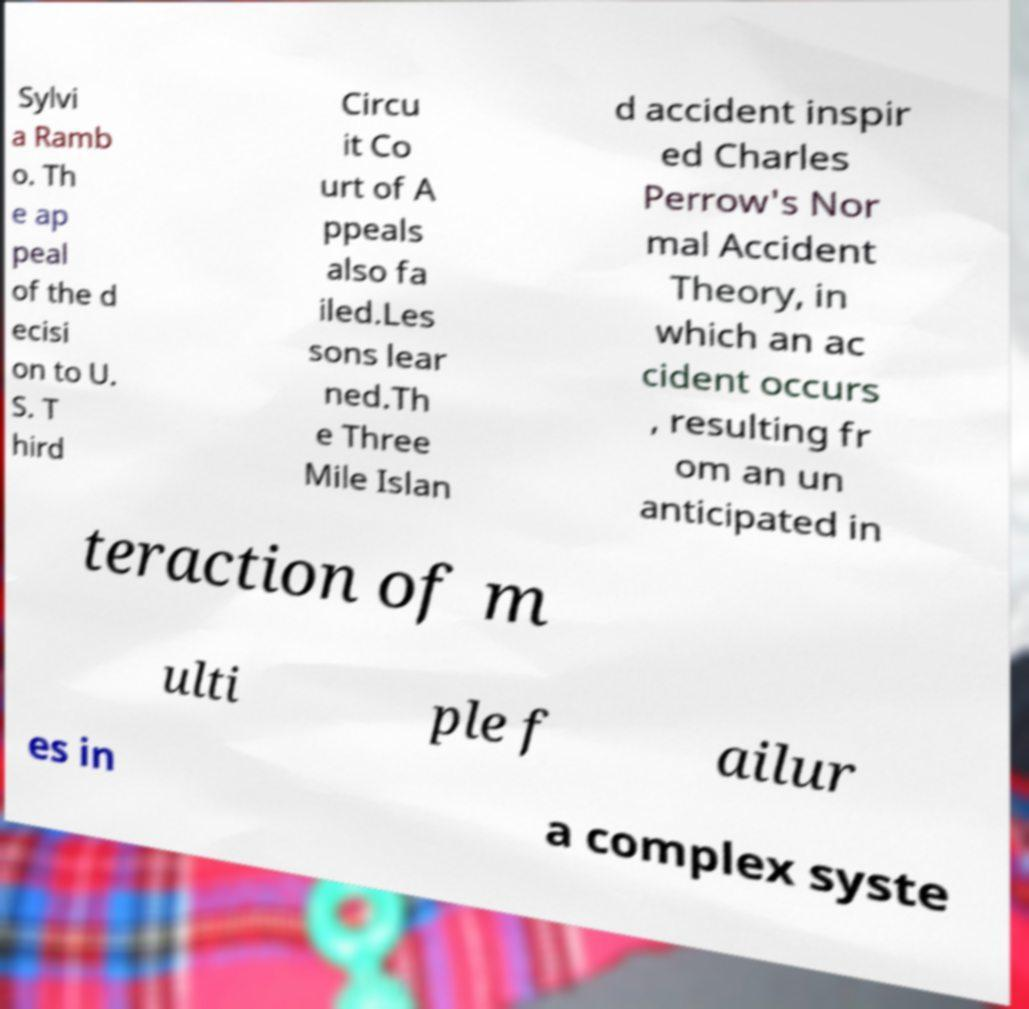Please identify and transcribe the text found in this image. Sylvi a Ramb o. Th e ap peal of the d ecisi on to U. S. T hird Circu it Co urt of A ppeals also fa iled.Les sons lear ned.Th e Three Mile Islan d accident inspir ed Charles Perrow's Nor mal Accident Theory, in which an ac cident occurs , resulting fr om an un anticipated in teraction of m ulti ple f ailur es in a complex syste 